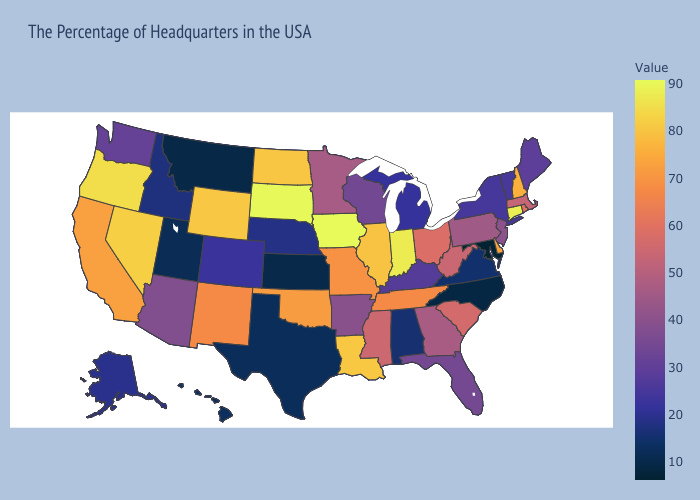Among the states that border New Mexico , does Arizona have the highest value?
Write a very short answer. No. Does Kansas have the lowest value in the MidWest?
Short answer required. Yes. Does Colorado have a lower value than Texas?
Answer briefly. No. Is the legend a continuous bar?
Write a very short answer. Yes. Does Pennsylvania have a higher value than Rhode Island?
Concise answer only. No. Which states have the highest value in the USA?
Keep it brief. Iowa. 